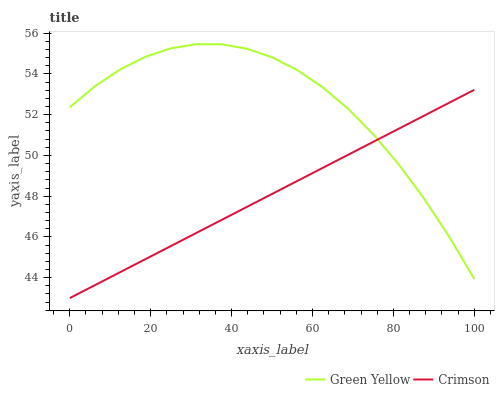Does Crimson have the minimum area under the curve?
Answer yes or no. Yes. Does Green Yellow have the maximum area under the curve?
Answer yes or no. Yes. Does Green Yellow have the minimum area under the curve?
Answer yes or no. No. Is Crimson the smoothest?
Answer yes or no. Yes. Is Green Yellow the roughest?
Answer yes or no. Yes. Is Green Yellow the smoothest?
Answer yes or no. No. Does Crimson have the lowest value?
Answer yes or no. Yes. Does Green Yellow have the lowest value?
Answer yes or no. No. Does Green Yellow have the highest value?
Answer yes or no. Yes. Does Crimson intersect Green Yellow?
Answer yes or no. Yes. Is Crimson less than Green Yellow?
Answer yes or no. No. Is Crimson greater than Green Yellow?
Answer yes or no. No. 